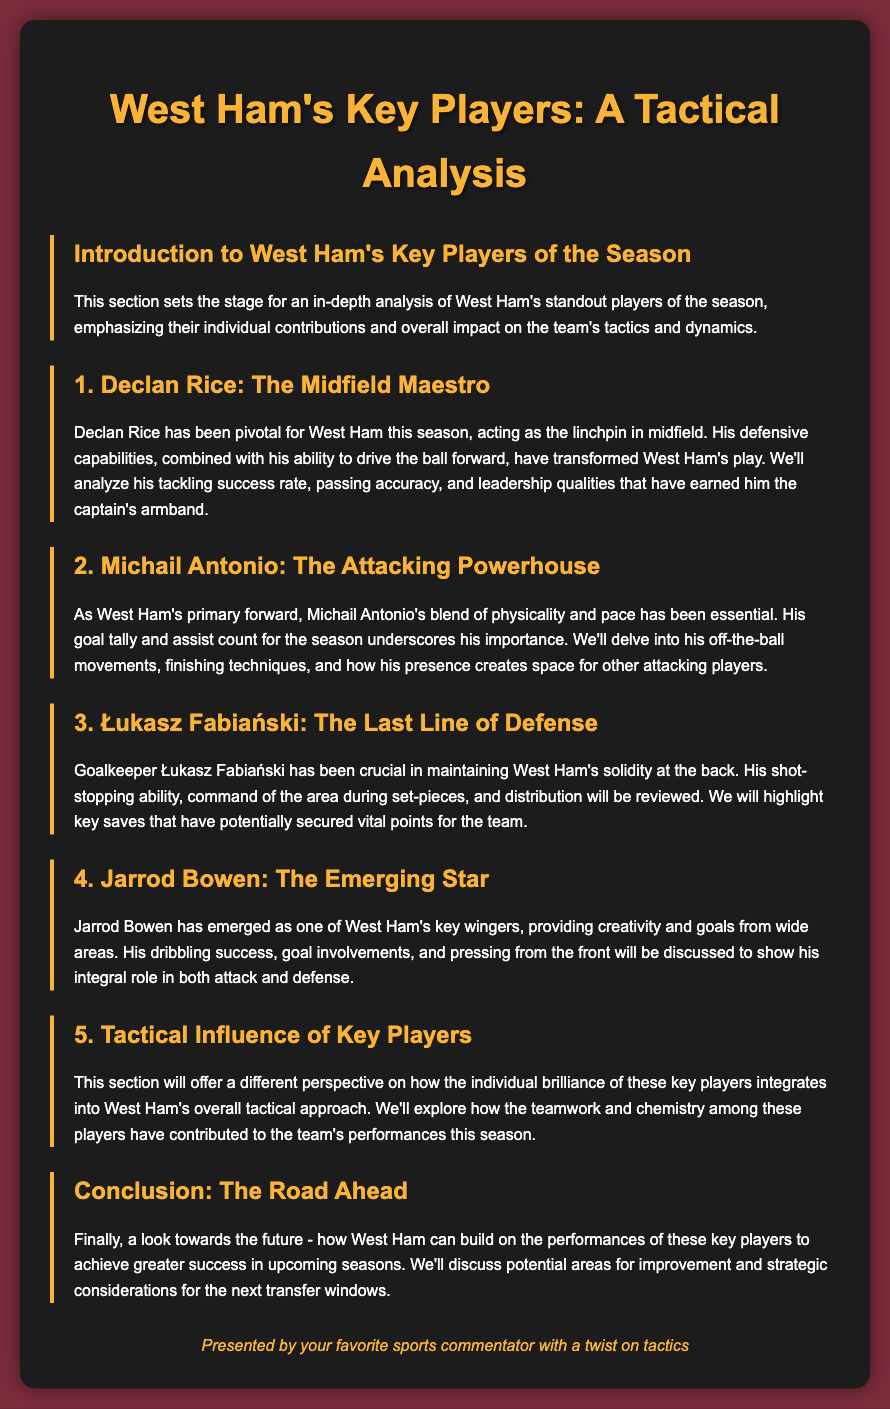What is the title of the document? The title of the document is indicated in the header section of the HTML.
Answer: West Ham's Key Players: A Tactical Analysis Who is the midfield maestro discussed in the document? The document explicitly names the individual recognized as the midfield maestro.
Answer: Declan Rice Which player is described as the attacking powerhouse? The text highlights a specific player’s role and contribution, labeling him as an attacking powerhouse.
Answer: Michail Antonio What position does Łukasz Fabiański play? The document categorizes Łukasz Fabiański's position within the context of the team's lineup.
Answer: Goalkeeper How many key players are analyzed in the document? The section headings indicate the total number of key players being discussed.
Answer: Four Which player is referred to as the emerging star? The document specifically identifies one player as an emerging star in West Ham's lineup.
Answer: Jarrod Bowen What is emphasized about the tactical influence of key players? This section notes the overall aspect of teamwork and integration in West Ham’s tactics.
Answer: Teamwork and chemistry What does the conclusion focus on? The conclusion section outlines future considerations for the team based on past performances.
Answer: Future success and improvement 